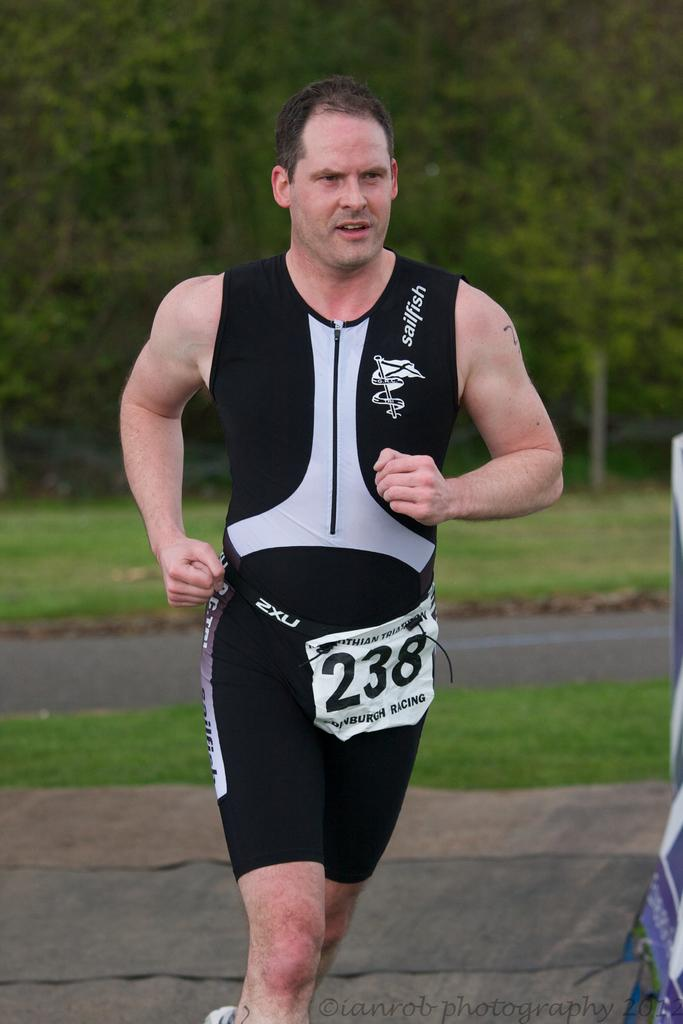Provide a one-sentence caption for the provided image. Runner 238 is wearing a tight black outfit. 